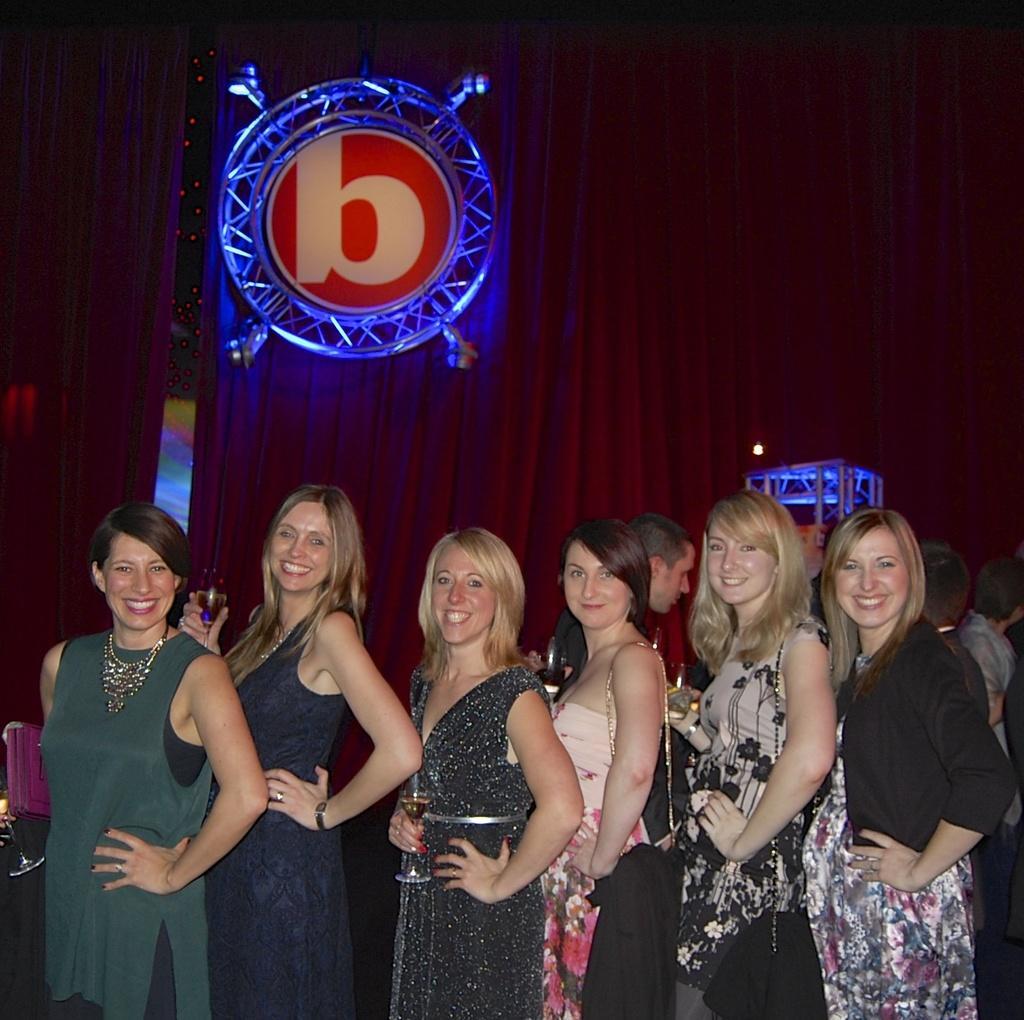Can you describe this image briefly? In this picture there are some girls standing in the front, smiling and giving a pose into the camera. Behind there is a red color curtain and round iron frame disk. 